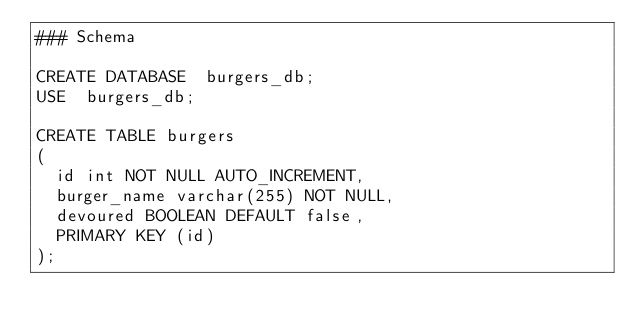Convert code to text. <code><loc_0><loc_0><loc_500><loc_500><_SQL_>### Schema

CREATE DATABASE  burgers_db;
USE  burgers_db;

CREATE TABLE burgers
(
	id int NOT NULL AUTO_INCREMENT,
	burger_name varchar(255) NOT NULL,
	devoured BOOLEAN DEFAULT false,
	PRIMARY KEY (id)
);
</code> 